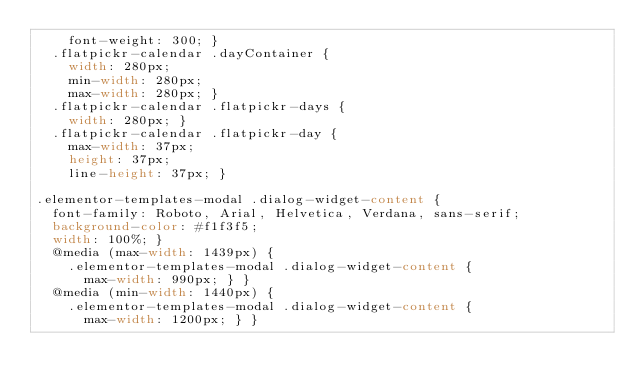<code> <loc_0><loc_0><loc_500><loc_500><_CSS_>    font-weight: 300; }
  .flatpickr-calendar .dayContainer {
    width: 280px;
    min-width: 280px;
    max-width: 280px; }
  .flatpickr-calendar .flatpickr-days {
    width: 280px; }
  .flatpickr-calendar .flatpickr-day {
    max-width: 37px;
    height: 37px;
    line-height: 37px; }

.elementor-templates-modal .dialog-widget-content {
  font-family: Roboto, Arial, Helvetica, Verdana, sans-serif;
  background-color: #f1f3f5;
  width: 100%; }
  @media (max-width: 1439px) {
    .elementor-templates-modal .dialog-widget-content {
      max-width: 990px; } }
  @media (min-width: 1440px) {
    .elementor-templates-modal .dialog-widget-content {
      max-width: 1200px; } }
</code> 